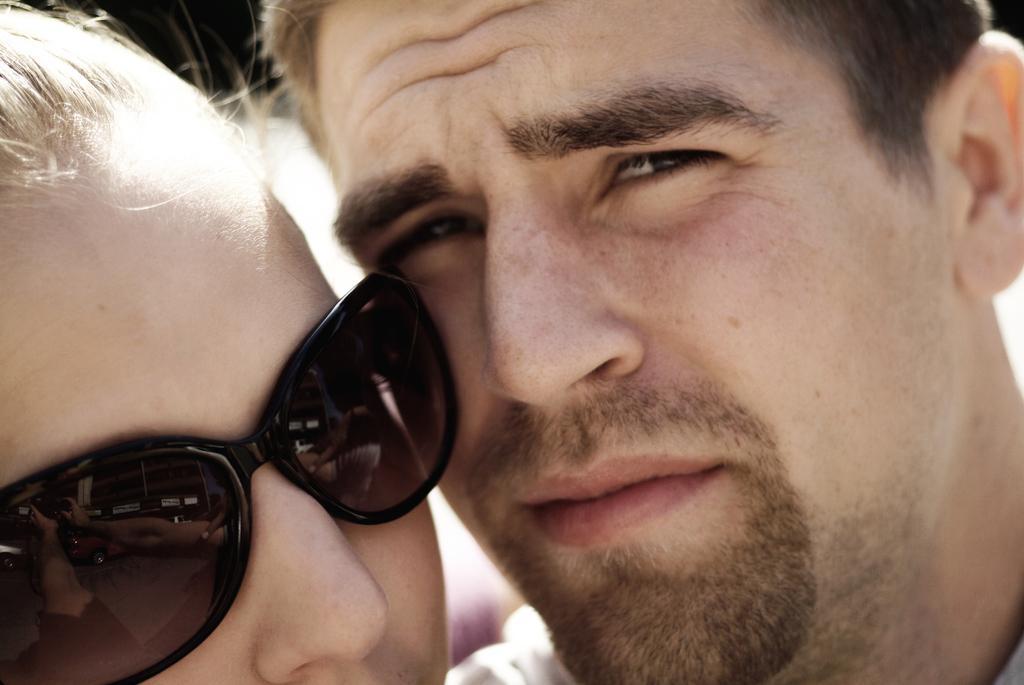Describe this image in one or two sentences. In this picture we can see one man and one women are taking pictures. 